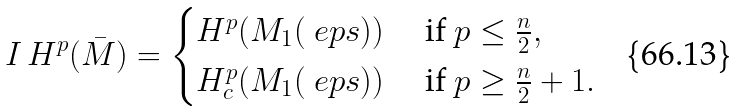Convert formula to latex. <formula><loc_0><loc_0><loc_500><loc_500>I \, H ^ { p } ( \bar { M } ) = \begin{cases} H ^ { p } ( M _ { 1 } ( \ e p s ) ) & \text { if } p \leq \frac { n } { 2 } , \\ H ^ { p } _ { c } ( M _ { 1 } ( \ e p s ) ) & \text { if } p \geq \frac { n } { 2 } + 1 . \end{cases}</formula> 